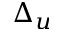Convert formula to latex. <formula><loc_0><loc_0><loc_500><loc_500>\Delta _ { u }</formula> 